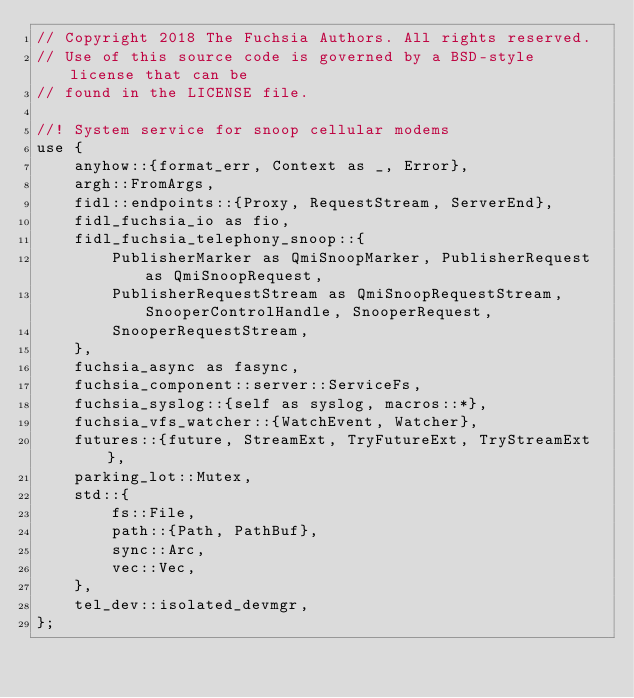<code> <loc_0><loc_0><loc_500><loc_500><_Rust_>// Copyright 2018 The Fuchsia Authors. All rights reserved.
// Use of this source code is governed by a BSD-style license that can be
// found in the LICENSE file.

//! System service for snoop cellular modems
use {
    anyhow::{format_err, Context as _, Error},
    argh::FromArgs,
    fidl::endpoints::{Proxy, RequestStream, ServerEnd},
    fidl_fuchsia_io as fio,
    fidl_fuchsia_telephony_snoop::{
        PublisherMarker as QmiSnoopMarker, PublisherRequest as QmiSnoopRequest,
        PublisherRequestStream as QmiSnoopRequestStream, SnooperControlHandle, SnooperRequest,
        SnooperRequestStream,
    },
    fuchsia_async as fasync,
    fuchsia_component::server::ServiceFs,
    fuchsia_syslog::{self as syslog, macros::*},
    fuchsia_vfs_watcher::{WatchEvent, Watcher},
    futures::{future, StreamExt, TryFutureExt, TryStreamExt},
    parking_lot::Mutex,
    std::{
        fs::File,
        path::{Path, PathBuf},
        sync::Arc,
        vec::Vec,
    },
    tel_dev::isolated_devmgr,
};
</code> 